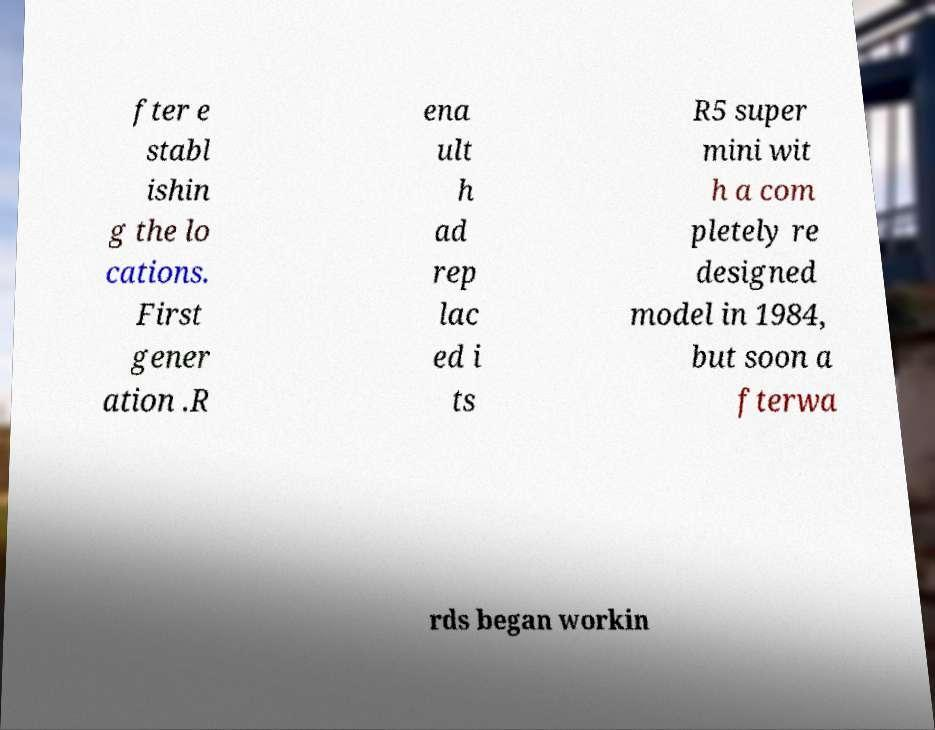Please read and relay the text visible in this image. What does it say? fter e stabl ishin g the lo cations. First gener ation .R ena ult h ad rep lac ed i ts R5 super mini wit h a com pletely re designed model in 1984, but soon a fterwa rds began workin 